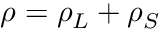Convert formula to latex. <formula><loc_0><loc_0><loc_500><loc_500>\rho = \rho _ { L } + \rho _ { S }</formula> 